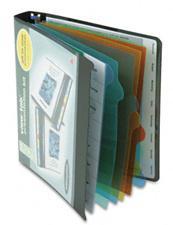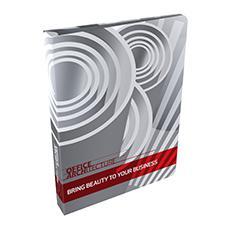The first image is the image on the left, the second image is the image on the right. Analyze the images presented: Is the assertion "There is one binder in the the image on the right." valid? Answer yes or no. Yes. The first image is the image on the left, the second image is the image on the right. Assess this claim about the two images: "At least one image shows binders lying on their sides, in a kind of stack.". Correct or not? Answer yes or no. No. 